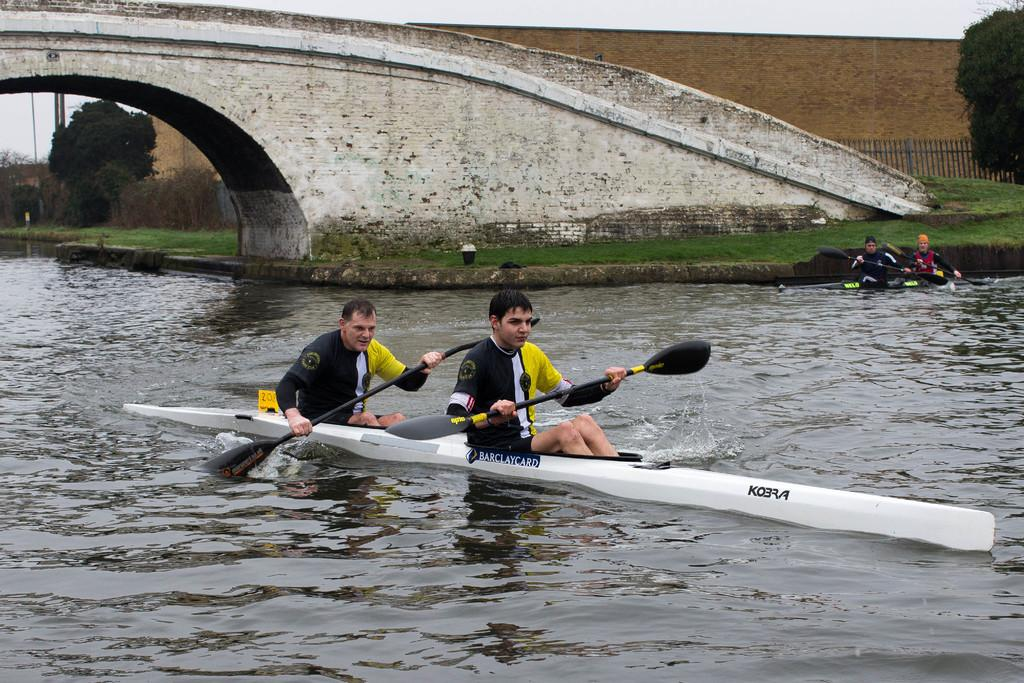What activity are the people in the image engaged in? The people in the image are rowing boats on the water. What structure can be seen in the image? There is a bridge visible in the image. What type of vegetation is present in the image? There is grass in the image. What can be seen in the background of the image? Trees, a fence, a wall, and the sky are visible in the background of the image. What color is the shirt worn by the person standing on the floor in the image? There is no person standing on the floor in the image; the people are rowing boats on the water. 